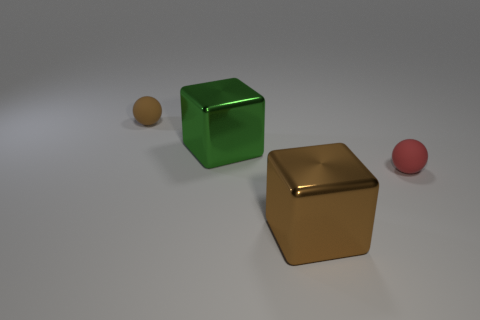What number of green objects are in front of the rubber thing on the right side of the large shiny cube behind the small red thing?
Offer a very short reply. 0. What number of other objects are the same material as the big green block?
Provide a succinct answer. 1. There is a brown thing that is the same size as the green metal object; what is it made of?
Ensure brevity in your answer.  Metal. There is a small object that is to the right of the small brown ball; does it have the same color as the big metallic thing behind the red rubber sphere?
Give a very brief answer. No. Is there a small rubber thing that has the same shape as the brown metal object?
Your answer should be compact. No. There is a green metal thing that is the same size as the brown metallic cube; what is its shape?
Your answer should be very brief. Cube. There is a sphere that is to the right of the brown matte object; what size is it?
Give a very brief answer. Small. What number of green metal objects are the same size as the brown ball?
Provide a short and direct response. 0. What is the color of the large object that is the same material as the brown cube?
Provide a succinct answer. Green. Is the number of large brown objects that are in front of the tiny red sphere less than the number of small yellow rubber blocks?
Your response must be concise. No. 